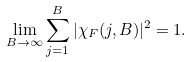Convert formula to latex. <formula><loc_0><loc_0><loc_500><loc_500>\lim _ { B \to \infty } \sum _ { j = 1 } ^ { B } | \chi _ { F } ( j , B ) | ^ { 2 } = 1 .</formula> 